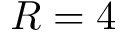Convert formula to latex. <formula><loc_0><loc_0><loc_500><loc_500>R = 4</formula> 